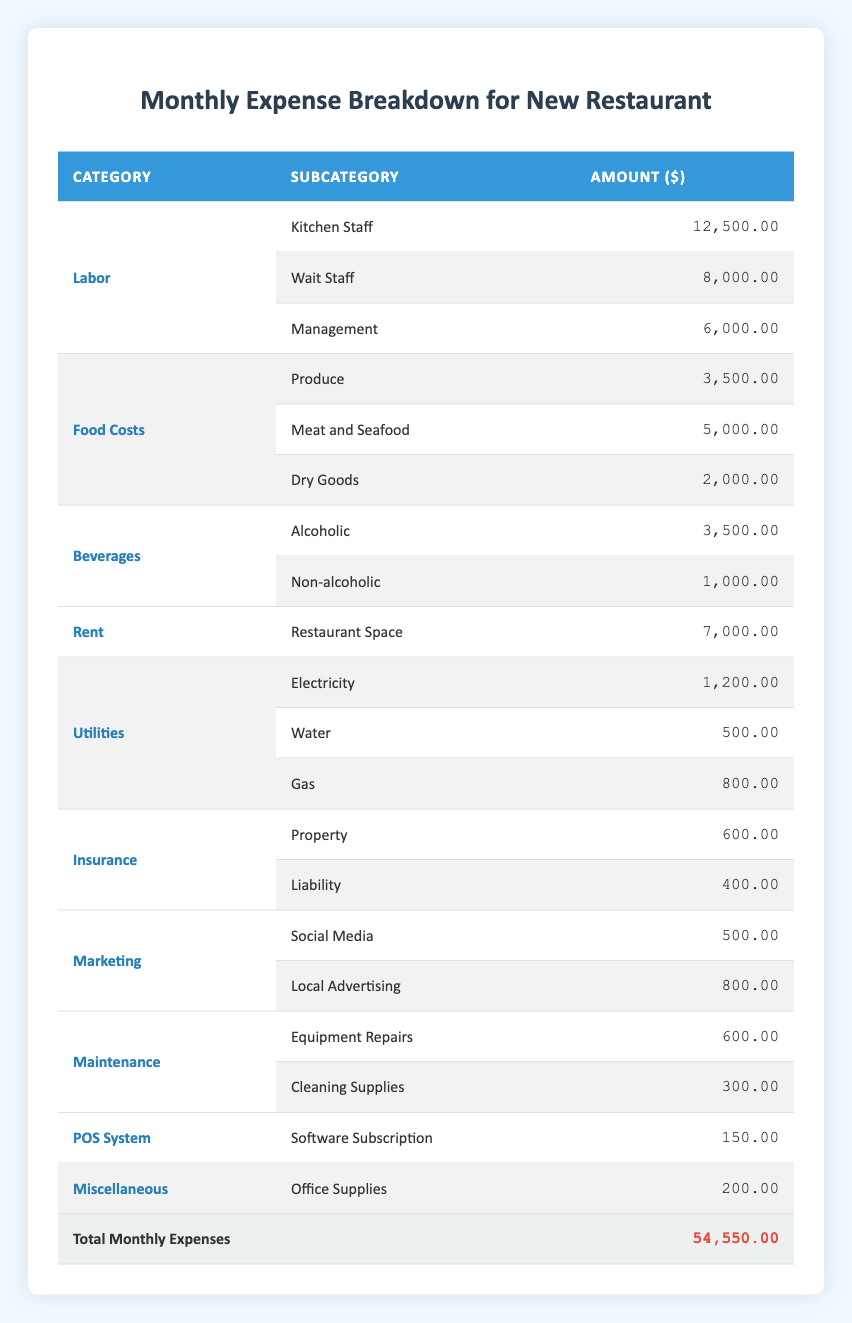What is the total monthly expense for the restaurant? The table shows a row for "Total Monthly Expenses," indicating all expense categories combined. The amount listed is 54,550.00.
Answer: 54,550.00 How much is spent on Labor compared to Food Costs? The total for Labor is calculated by adding the individual amounts: 12,500 (Kitchen Staff) + 8,000 (Wait Staff) + 6,000 (Management) = 26,500. For Food Costs, it's 3,500 (Produce) + 5,000 (Meat and Seafood) + 2,000 (Dry Goods) = 10,500. Comparing these, Labor costs 26,500 while Food Costs are 10,500.
Answer: Labor is 26,500 and Food Costs are 10,500 Is the amount spent on Beverages greater than the amount for Insurance? The total for Beverages is 3,500 (Alcoholic) + 1,000 (Non-alcoholic) = 4,500. The total for Insurance is 600 (Property) + 400 (Liability) = 1,000. Since 4,500 is greater than 1,000, the statement is true.
Answer: Yes What is the average expense for the Utilities category? The total for Utilities is 1,200 (Electricity) + 500 (Water) + 800 (Gas) = 2,500. There are 3 subcategories, so the average is calculated as 2,500 / 3 = 833.33.
Answer: 833.33 Which category has the highest expense, and what is that amount? Among all categories, Labor has the largest individual total expense at 26,500. None of the other categories exceed this value.
Answer: Labor, 26,500 How much is spent on marketing in total? Marketing expenses go to two subcategories: 500 (Social Media) and 800 (Local Advertising). Adding these gives a total of 1,300 for Marketing.
Answer: 1,300 Is the Insurance expense greater than the Maintenance expense? The total for Insurance is 600 (Property) + 400 (Liability) = 1,000, while Maintenance totals to 600 (Equipment Repairs) + 300 (Cleaning Supplies) = 900. Since 1,000 is greater than 900, the statement is true.
Answer: Yes What percentage of the total expenses are dedicated to Rent? rent is 7,000. To find its percentage of total expenses: (7,000 / 54,550) * 100 = approximately 12.83%.
Answer: Approximately 12.83% Which Labor subcategory has the highest expense? Among the Labor subcategories, Kitchen Staff costs 12,500, Wait Staff costs 8,000, and Management costs 6,000. The highest is 12,500 for Kitchen Staff.
Answer: Kitchen Staff, 12,500 